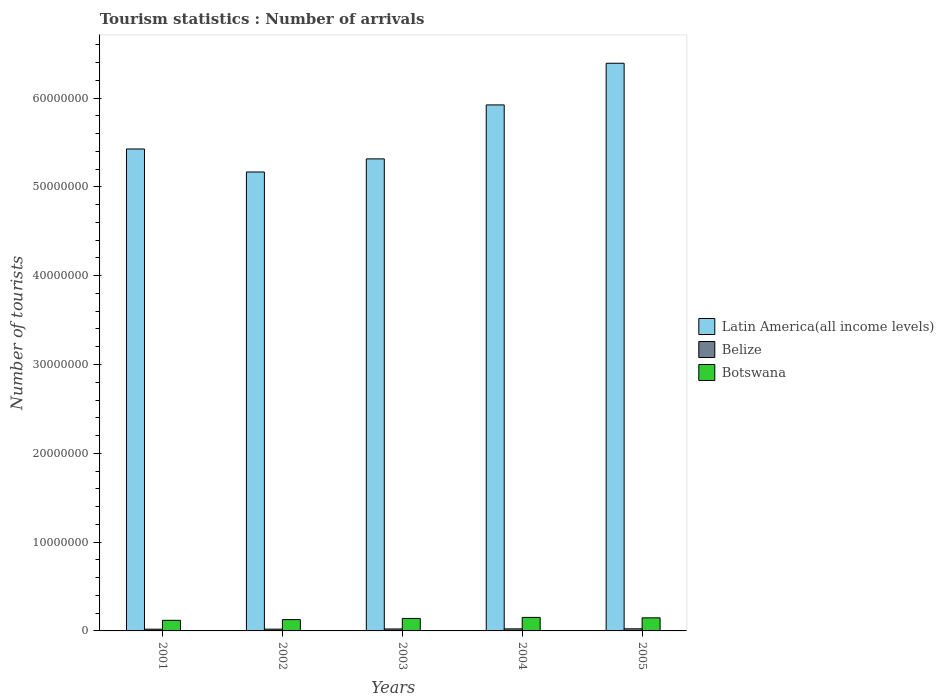How many groups of bars are there?
Offer a very short reply. 5. How many bars are there on the 4th tick from the left?
Your answer should be very brief. 3. What is the label of the 3rd group of bars from the left?
Offer a very short reply. 2003. What is the number of tourist arrivals in Botswana in 2001?
Offer a terse response. 1.19e+06. Across all years, what is the maximum number of tourist arrivals in Latin America(all income levels)?
Give a very brief answer. 6.39e+07. Across all years, what is the minimum number of tourist arrivals in Belize?
Provide a succinct answer. 1.96e+05. What is the total number of tourist arrivals in Latin America(all income levels) in the graph?
Your answer should be compact. 2.82e+08. What is the difference between the number of tourist arrivals in Botswana in 2001 and that in 2005?
Provide a short and direct response. -2.81e+05. What is the difference between the number of tourist arrivals in Belize in 2003 and the number of tourist arrivals in Botswana in 2002?
Your response must be concise. -1.05e+06. What is the average number of tourist arrivals in Belize per year?
Keep it short and to the point. 2.17e+05. In the year 2003, what is the difference between the number of tourist arrivals in Botswana and number of tourist arrivals in Latin America(all income levels)?
Your answer should be compact. -5.18e+07. In how many years, is the number of tourist arrivals in Belize greater than 8000000?
Make the answer very short. 0. What is the ratio of the number of tourist arrivals in Belize in 2003 to that in 2004?
Ensure brevity in your answer.  0.96. Is the difference between the number of tourist arrivals in Botswana in 2002 and 2004 greater than the difference between the number of tourist arrivals in Latin America(all income levels) in 2002 and 2004?
Your response must be concise. Yes. What is the difference between the highest and the second highest number of tourist arrivals in Botswana?
Give a very brief answer. 4.90e+04. What is the difference between the highest and the lowest number of tourist arrivals in Botswana?
Make the answer very short. 3.30e+05. In how many years, is the number of tourist arrivals in Latin America(all income levels) greater than the average number of tourist arrivals in Latin America(all income levels) taken over all years?
Keep it short and to the point. 2. What does the 3rd bar from the left in 2004 represents?
Offer a terse response. Botswana. What does the 1st bar from the right in 2005 represents?
Offer a terse response. Botswana. Is it the case that in every year, the sum of the number of tourist arrivals in Belize and number of tourist arrivals in Latin America(all income levels) is greater than the number of tourist arrivals in Botswana?
Offer a terse response. Yes. Are all the bars in the graph horizontal?
Offer a terse response. No. How many years are there in the graph?
Provide a short and direct response. 5. Does the graph contain grids?
Make the answer very short. No. What is the title of the graph?
Make the answer very short. Tourism statistics : Number of arrivals. Does "Isle of Man" appear as one of the legend labels in the graph?
Your response must be concise. No. What is the label or title of the Y-axis?
Your response must be concise. Number of tourists. What is the Number of tourists in Latin America(all income levels) in 2001?
Keep it short and to the point. 5.43e+07. What is the Number of tourists of Belize in 2001?
Provide a succinct answer. 1.96e+05. What is the Number of tourists in Botswana in 2001?
Provide a short and direct response. 1.19e+06. What is the Number of tourists in Latin America(all income levels) in 2002?
Your response must be concise. 5.17e+07. What is the Number of tourists of Belize in 2002?
Provide a short and direct response. 2.00e+05. What is the Number of tourists of Botswana in 2002?
Your answer should be compact. 1.27e+06. What is the Number of tourists of Latin America(all income levels) in 2003?
Make the answer very short. 5.32e+07. What is the Number of tourists in Belize in 2003?
Your answer should be compact. 2.21e+05. What is the Number of tourists of Botswana in 2003?
Make the answer very short. 1.41e+06. What is the Number of tourists in Latin America(all income levels) in 2004?
Offer a very short reply. 5.92e+07. What is the Number of tourists of Belize in 2004?
Provide a short and direct response. 2.31e+05. What is the Number of tourists in Botswana in 2004?
Your answer should be compact. 1.52e+06. What is the Number of tourists in Latin America(all income levels) in 2005?
Give a very brief answer. 6.39e+07. What is the Number of tourists in Belize in 2005?
Your answer should be very brief. 2.37e+05. What is the Number of tourists in Botswana in 2005?
Your answer should be very brief. 1.47e+06. Across all years, what is the maximum Number of tourists in Latin America(all income levels)?
Your response must be concise. 6.39e+07. Across all years, what is the maximum Number of tourists in Belize?
Your response must be concise. 2.37e+05. Across all years, what is the maximum Number of tourists in Botswana?
Keep it short and to the point. 1.52e+06. Across all years, what is the minimum Number of tourists of Latin America(all income levels)?
Offer a terse response. 5.17e+07. Across all years, what is the minimum Number of tourists in Belize?
Ensure brevity in your answer.  1.96e+05. Across all years, what is the minimum Number of tourists in Botswana?
Offer a terse response. 1.19e+06. What is the total Number of tourists of Latin America(all income levels) in the graph?
Offer a very short reply. 2.82e+08. What is the total Number of tourists of Belize in the graph?
Offer a terse response. 1.08e+06. What is the total Number of tourists in Botswana in the graph?
Provide a succinct answer. 6.87e+06. What is the difference between the Number of tourists in Latin America(all income levels) in 2001 and that in 2002?
Provide a short and direct response. 2.59e+06. What is the difference between the Number of tourists of Belize in 2001 and that in 2002?
Ensure brevity in your answer.  -4000. What is the difference between the Number of tourists in Botswana in 2001 and that in 2002?
Your response must be concise. -8.10e+04. What is the difference between the Number of tourists in Latin America(all income levels) in 2001 and that in 2003?
Ensure brevity in your answer.  1.12e+06. What is the difference between the Number of tourists of Belize in 2001 and that in 2003?
Offer a terse response. -2.50e+04. What is the difference between the Number of tourists in Botswana in 2001 and that in 2003?
Offer a terse response. -2.13e+05. What is the difference between the Number of tourists of Latin America(all income levels) in 2001 and that in 2004?
Ensure brevity in your answer.  -4.96e+06. What is the difference between the Number of tourists in Belize in 2001 and that in 2004?
Your answer should be very brief. -3.50e+04. What is the difference between the Number of tourists in Botswana in 2001 and that in 2004?
Ensure brevity in your answer.  -3.30e+05. What is the difference between the Number of tourists in Latin America(all income levels) in 2001 and that in 2005?
Offer a terse response. -9.65e+06. What is the difference between the Number of tourists in Belize in 2001 and that in 2005?
Your answer should be very brief. -4.10e+04. What is the difference between the Number of tourists of Botswana in 2001 and that in 2005?
Your answer should be compact. -2.81e+05. What is the difference between the Number of tourists in Latin America(all income levels) in 2002 and that in 2003?
Offer a very short reply. -1.47e+06. What is the difference between the Number of tourists of Belize in 2002 and that in 2003?
Give a very brief answer. -2.10e+04. What is the difference between the Number of tourists in Botswana in 2002 and that in 2003?
Your answer should be compact. -1.32e+05. What is the difference between the Number of tourists of Latin America(all income levels) in 2002 and that in 2004?
Offer a very short reply. -7.55e+06. What is the difference between the Number of tourists of Belize in 2002 and that in 2004?
Provide a succinct answer. -3.10e+04. What is the difference between the Number of tourists in Botswana in 2002 and that in 2004?
Offer a very short reply. -2.49e+05. What is the difference between the Number of tourists of Latin America(all income levels) in 2002 and that in 2005?
Ensure brevity in your answer.  -1.22e+07. What is the difference between the Number of tourists in Belize in 2002 and that in 2005?
Provide a succinct answer. -3.70e+04. What is the difference between the Number of tourists in Botswana in 2002 and that in 2005?
Your response must be concise. -2.00e+05. What is the difference between the Number of tourists in Latin America(all income levels) in 2003 and that in 2004?
Your answer should be compact. -6.08e+06. What is the difference between the Number of tourists of Belize in 2003 and that in 2004?
Provide a short and direct response. -10000. What is the difference between the Number of tourists in Botswana in 2003 and that in 2004?
Your answer should be very brief. -1.17e+05. What is the difference between the Number of tourists of Latin America(all income levels) in 2003 and that in 2005?
Keep it short and to the point. -1.08e+07. What is the difference between the Number of tourists in Belize in 2003 and that in 2005?
Your answer should be very brief. -1.60e+04. What is the difference between the Number of tourists of Botswana in 2003 and that in 2005?
Offer a terse response. -6.80e+04. What is the difference between the Number of tourists in Latin America(all income levels) in 2004 and that in 2005?
Your answer should be compact. -4.69e+06. What is the difference between the Number of tourists of Belize in 2004 and that in 2005?
Offer a terse response. -6000. What is the difference between the Number of tourists of Botswana in 2004 and that in 2005?
Give a very brief answer. 4.90e+04. What is the difference between the Number of tourists of Latin America(all income levels) in 2001 and the Number of tourists of Belize in 2002?
Your answer should be compact. 5.41e+07. What is the difference between the Number of tourists in Latin America(all income levels) in 2001 and the Number of tourists in Botswana in 2002?
Provide a succinct answer. 5.30e+07. What is the difference between the Number of tourists of Belize in 2001 and the Number of tourists of Botswana in 2002?
Provide a succinct answer. -1.08e+06. What is the difference between the Number of tourists in Latin America(all income levels) in 2001 and the Number of tourists in Belize in 2003?
Offer a very short reply. 5.41e+07. What is the difference between the Number of tourists in Latin America(all income levels) in 2001 and the Number of tourists in Botswana in 2003?
Ensure brevity in your answer.  5.29e+07. What is the difference between the Number of tourists of Belize in 2001 and the Number of tourists of Botswana in 2003?
Offer a very short reply. -1.21e+06. What is the difference between the Number of tourists in Latin America(all income levels) in 2001 and the Number of tourists in Belize in 2004?
Your response must be concise. 5.40e+07. What is the difference between the Number of tourists in Latin America(all income levels) in 2001 and the Number of tourists in Botswana in 2004?
Your answer should be very brief. 5.27e+07. What is the difference between the Number of tourists of Belize in 2001 and the Number of tourists of Botswana in 2004?
Provide a succinct answer. -1.33e+06. What is the difference between the Number of tourists in Latin America(all income levels) in 2001 and the Number of tourists in Belize in 2005?
Keep it short and to the point. 5.40e+07. What is the difference between the Number of tourists in Latin America(all income levels) in 2001 and the Number of tourists in Botswana in 2005?
Provide a short and direct response. 5.28e+07. What is the difference between the Number of tourists of Belize in 2001 and the Number of tourists of Botswana in 2005?
Offer a terse response. -1.28e+06. What is the difference between the Number of tourists of Latin America(all income levels) in 2002 and the Number of tourists of Belize in 2003?
Provide a short and direct response. 5.15e+07. What is the difference between the Number of tourists of Latin America(all income levels) in 2002 and the Number of tourists of Botswana in 2003?
Ensure brevity in your answer.  5.03e+07. What is the difference between the Number of tourists of Belize in 2002 and the Number of tourists of Botswana in 2003?
Your response must be concise. -1.21e+06. What is the difference between the Number of tourists in Latin America(all income levels) in 2002 and the Number of tourists in Belize in 2004?
Give a very brief answer. 5.15e+07. What is the difference between the Number of tourists in Latin America(all income levels) in 2002 and the Number of tourists in Botswana in 2004?
Give a very brief answer. 5.02e+07. What is the difference between the Number of tourists in Belize in 2002 and the Number of tourists in Botswana in 2004?
Your answer should be very brief. -1.32e+06. What is the difference between the Number of tourists of Latin America(all income levels) in 2002 and the Number of tourists of Belize in 2005?
Keep it short and to the point. 5.14e+07. What is the difference between the Number of tourists in Latin America(all income levels) in 2002 and the Number of tourists in Botswana in 2005?
Provide a succinct answer. 5.02e+07. What is the difference between the Number of tourists in Belize in 2002 and the Number of tourists in Botswana in 2005?
Give a very brief answer. -1.27e+06. What is the difference between the Number of tourists of Latin America(all income levels) in 2003 and the Number of tourists of Belize in 2004?
Offer a very short reply. 5.29e+07. What is the difference between the Number of tourists in Latin America(all income levels) in 2003 and the Number of tourists in Botswana in 2004?
Keep it short and to the point. 5.16e+07. What is the difference between the Number of tourists of Belize in 2003 and the Number of tourists of Botswana in 2004?
Provide a short and direct response. -1.30e+06. What is the difference between the Number of tourists of Latin America(all income levels) in 2003 and the Number of tourists of Belize in 2005?
Provide a short and direct response. 5.29e+07. What is the difference between the Number of tourists in Latin America(all income levels) in 2003 and the Number of tourists in Botswana in 2005?
Make the answer very short. 5.17e+07. What is the difference between the Number of tourists in Belize in 2003 and the Number of tourists in Botswana in 2005?
Your answer should be compact. -1.25e+06. What is the difference between the Number of tourists in Latin America(all income levels) in 2004 and the Number of tourists in Belize in 2005?
Provide a succinct answer. 5.90e+07. What is the difference between the Number of tourists of Latin America(all income levels) in 2004 and the Number of tourists of Botswana in 2005?
Your answer should be compact. 5.78e+07. What is the difference between the Number of tourists of Belize in 2004 and the Number of tourists of Botswana in 2005?
Offer a terse response. -1.24e+06. What is the average Number of tourists in Latin America(all income levels) per year?
Your answer should be very brief. 5.65e+07. What is the average Number of tourists of Belize per year?
Provide a succinct answer. 2.17e+05. What is the average Number of tourists of Botswana per year?
Your answer should be very brief. 1.37e+06. In the year 2001, what is the difference between the Number of tourists in Latin America(all income levels) and Number of tourists in Belize?
Offer a terse response. 5.41e+07. In the year 2001, what is the difference between the Number of tourists of Latin America(all income levels) and Number of tourists of Botswana?
Keep it short and to the point. 5.31e+07. In the year 2001, what is the difference between the Number of tourists in Belize and Number of tourists in Botswana?
Ensure brevity in your answer.  -9.97e+05. In the year 2002, what is the difference between the Number of tourists of Latin America(all income levels) and Number of tourists of Belize?
Provide a succinct answer. 5.15e+07. In the year 2002, what is the difference between the Number of tourists of Latin America(all income levels) and Number of tourists of Botswana?
Offer a terse response. 5.04e+07. In the year 2002, what is the difference between the Number of tourists of Belize and Number of tourists of Botswana?
Make the answer very short. -1.07e+06. In the year 2003, what is the difference between the Number of tourists in Latin America(all income levels) and Number of tourists in Belize?
Offer a terse response. 5.29e+07. In the year 2003, what is the difference between the Number of tourists of Latin America(all income levels) and Number of tourists of Botswana?
Ensure brevity in your answer.  5.18e+07. In the year 2003, what is the difference between the Number of tourists of Belize and Number of tourists of Botswana?
Make the answer very short. -1.18e+06. In the year 2004, what is the difference between the Number of tourists of Latin America(all income levels) and Number of tourists of Belize?
Ensure brevity in your answer.  5.90e+07. In the year 2004, what is the difference between the Number of tourists of Latin America(all income levels) and Number of tourists of Botswana?
Your answer should be compact. 5.77e+07. In the year 2004, what is the difference between the Number of tourists in Belize and Number of tourists in Botswana?
Offer a very short reply. -1.29e+06. In the year 2005, what is the difference between the Number of tourists in Latin America(all income levels) and Number of tourists in Belize?
Offer a very short reply. 6.37e+07. In the year 2005, what is the difference between the Number of tourists in Latin America(all income levels) and Number of tourists in Botswana?
Give a very brief answer. 6.25e+07. In the year 2005, what is the difference between the Number of tourists of Belize and Number of tourists of Botswana?
Provide a succinct answer. -1.24e+06. What is the ratio of the Number of tourists of Latin America(all income levels) in 2001 to that in 2002?
Give a very brief answer. 1.05. What is the ratio of the Number of tourists of Belize in 2001 to that in 2002?
Your response must be concise. 0.98. What is the ratio of the Number of tourists in Botswana in 2001 to that in 2002?
Give a very brief answer. 0.94. What is the ratio of the Number of tourists in Belize in 2001 to that in 2003?
Provide a succinct answer. 0.89. What is the ratio of the Number of tourists in Botswana in 2001 to that in 2003?
Offer a terse response. 0.85. What is the ratio of the Number of tourists of Latin America(all income levels) in 2001 to that in 2004?
Offer a very short reply. 0.92. What is the ratio of the Number of tourists in Belize in 2001 to that in 2004?
Offer a very short reply. 0.85. What is the ratio of the Number of tourists in Botswana in 2001 to that in 2004?
Ensure brevity in your answer.  0.78. What is the ratio of the Number of tourists of Latin America(all income levels) in 2001 to that in 2005?
Your answer should be compact. 0.85. What is the ratio of the Number of tourists in Belize in 2001 to that in 2005?
Your response must be concise. 0.83. What is the ratio of the Number of tourists in Botswana in 2001 to that in 2005?
Offer a terse response. 0.81. What is the ratio of the Number of tourists in Latin America(all income levels) in 2002 to that in 2003?
Keep it short and to the point. 0.97. What is the ratio of the Number of tourists in Belize in 2002 to that in 2003?
Offer a terse response. 0.91. What is the ratio of the Number of tourists in Botswana in 2002 to that in 2003?
Keep it short and to the point. 0.91. What is the ratio of the Number of tourists in Latin America(all income levels) in 2002 to that in 2004?
Your response must be concise. 0.87. What is the ratio of the Number of tourists of Belize in 2002 to that in 2004?
Provide a succinct answer. 0.87. What is the ratio of the Number of tourists in Botswana in 2002 to that in 2004?
Your answer should be very brief. 0.84. What is the ratio of the Number of tourists of Latin America(all income levels) in 2002 to that in 2005?
Make the answer very short. 0.81. What is the ratio of the Number of tourists of Belize in 2002 to that in 2005?
Give a very brief answer. 0.84. What is the ratio of the Number of tourists of Botswana in 2002 to that in 2005?
Provide a succinct answer. 0.86. What is the ratio of the Number of tourists in Latin America(all income levels) in 2003 to that in 2004?
Your response must be concise. 0.9. What is the ratio of the Number of tourists of Belize in 2003 to that in 2004?
Give a very brief answer. 0.96. What is the ratio of the Number of tourists of Botswana in 2003 to that in 2004?
Ensure brevity in your answer.  0.92. What is the ratio of the Number of tourists of Latin America(all income levels) in 2003 to that in 2005?
Give a very brief answer. 0.83. What is the ratio of the Number of tourists of Belize in 2003 to that in 2005?
Offer a terse response. 0.93. What is the ratio of the Number of tourists of Botswana in 2003 to that in 2005?
Provide a short and direct response. 0.95. What is the ratio of the Number of tourists of Latin America(all income levels) in 2004 to that in 2005?
Ensure brevity in your answer.  0.93. What is the ratio of the Number of tourists of Belize in 2004 to that in 2005?
Your response must be concise. 0.97. What is the ratio of the Number of tourists in Botswana in 2004 to that in 2005?
Make the answer very short. 1.03. What is the difference between the highest and the second highest Number of tourists in Latin America(all income levels)?
Give a very brief answer. 4.69e+06. What is the difference between the highest and the second highest Number of tourists of Belize?
Provide a short and direct response. 6000. What is the difference between the highest and the second highest Number of tourists in Botswana?
Your answer should be very brief. 4.90e+04. What is the difference between the highest and the lowest Number of tourists in Latin America(all income levels)?
Provide a succinct answer. 1.22e+07. What is the difference between the highest and the lowest Number of tourists in Belize?
Provide a succinct answer. 4.10e+04. 